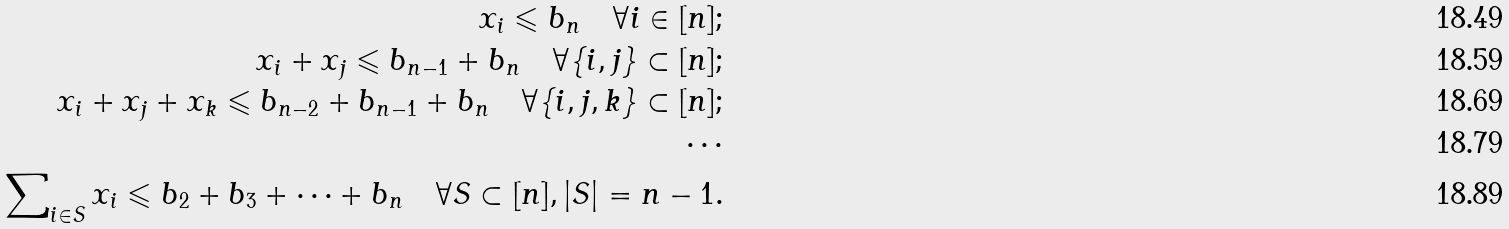Convert formula to latex. <formula><loc_0><loc_0><loc_500><loc_500>x _ { i } \leqslant b _ { n } \quad \forall i \in [ n ] ; \\ x _ { i } + x _ { j } \leqslant b _ { n - 1 } + b _ { n } \quad \forall \{ i , j \} \subset [ n ] ; \\ x _ { i } + x _ { j } + x _ { k } \leqslant b _ { n - 2 } + b _ { n - 1 } + b _ { n } \quad \forall \{ i , j , k \} \subset [ n ] ; \\ \cdots \\ \sum \nolimits _ { i \in S } x _ { i } \leqslant b _ { 2 } + b _ { 3 } + \cdots + b _ { n } \quad \forall S \subset [ n ] , | S | = n - 1 .</formula> 